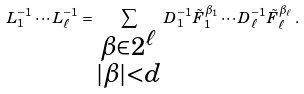Convert formula to latex. <formula><loc_0><loc_0><loc_500><loc_500>L _ { 1 } ^ { - 1 } \cdots L _ { \ell } ^ { - 1 } = \sum _ { \substack { \beta \in \mathbb { m } { 2 } ^ { \ell } \\ | \beta | < d } } D _ { 1 } ^ { - 1 } \tilde { F } _ { 1 } ^ { \beta _ { 1 } } \cdots D _ { \ell } ^ { - 1 } \tilde { F } _ { \ell } ^ { \beta _ { \ell } } \, .</formula> 